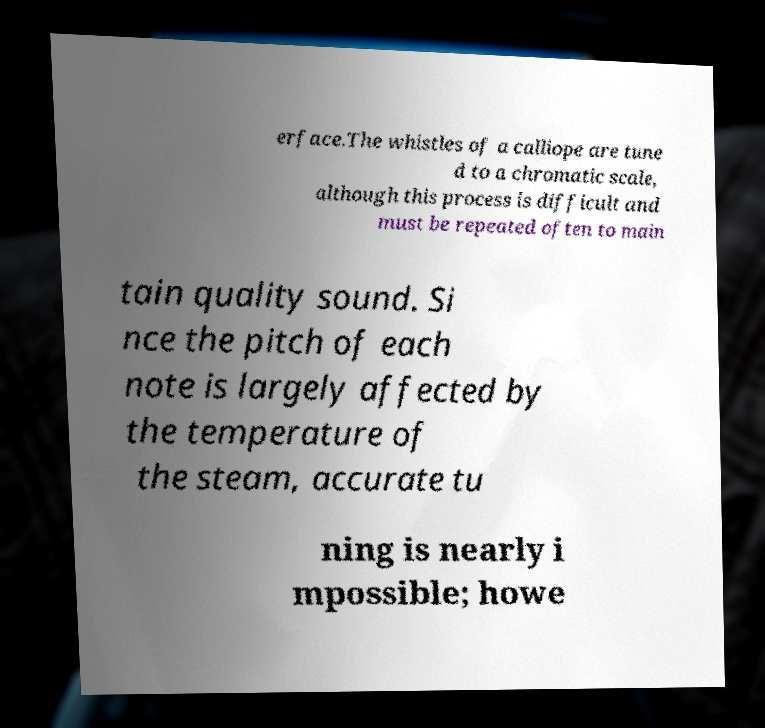What messages or text are displayed in this image? I need them in a readable, typed format. erface.The whistles of a calliope are tune d to a chromatic scale, although this process is difficult and must be repeated often to main tain quality sound. Si nce the pitch of each note is largely affected by the temperature of the steam, accurate tu ning is nearly i mpossible; howe 